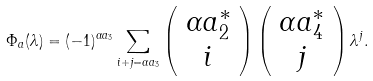<formula> <loc_0><loc_0><loc_500><loc_500>\Phi _ { a } ( \lambda ) = ( - 1 ) ^ { \alpha a _ { 3 } } \sum _ { i + j = \alpha a _ { 3 } } \left ( \begin{array} { c } \alpha a ^ { \ast } _ { 2 } \\ i \end{array} \right ) \left ( \begin{array} { c } \alpha a ^ { \ast } _ { 4 } \\ j \end{array} \right ) \lambda ^ { j } .</formula> 